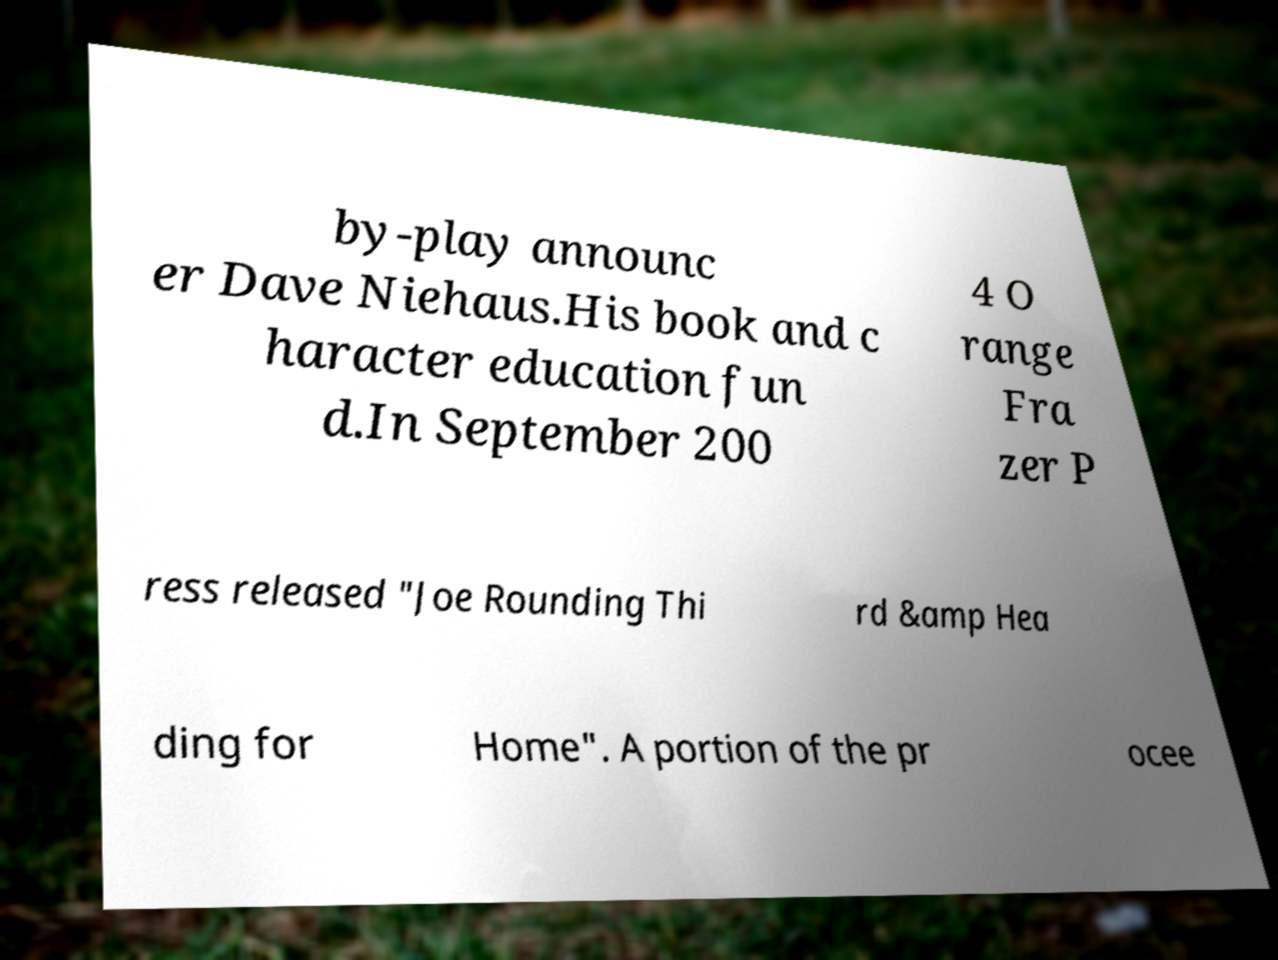I need the written content from this picture converted into text. Can you do that? by-play announc er Dave Niehaus.His book and c haracter education fun d.In September 200 4 O range Fra zer P ress released "Joe Rounding Thi rd &amp Hea ding for Home". A portion of the pr ocee 